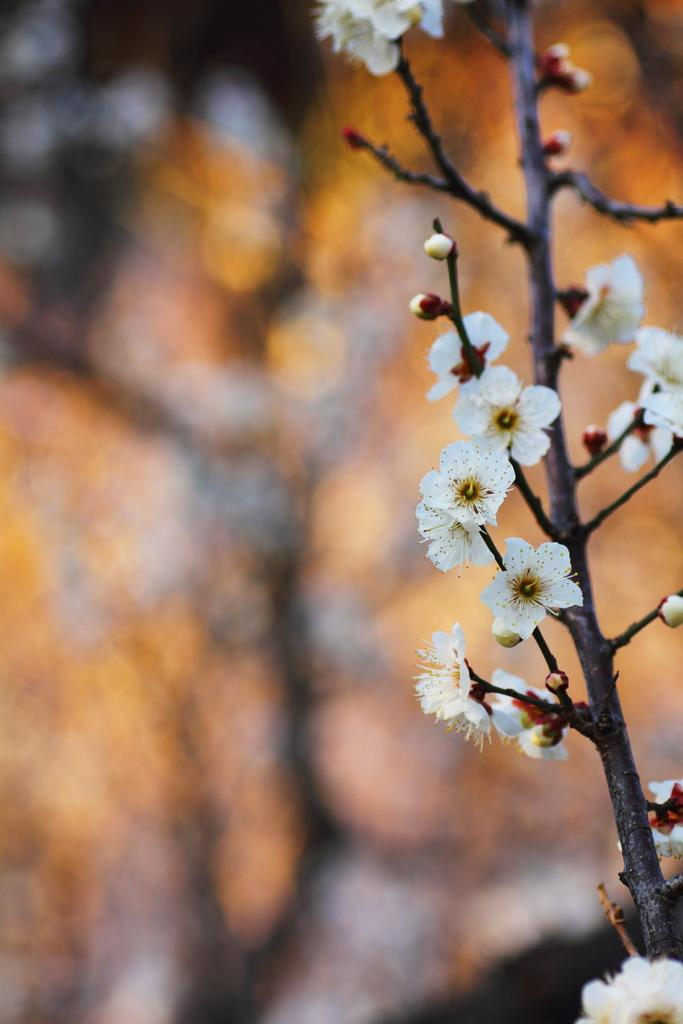What color are the flowers on the plant in the image? The flowers on the plant are white. What stage of growth are some of the flowers in? There are buds on the plant, indicating that some flowers are not yet fully bloomed. How would you describe the quality of the image's background? The image is blurry at the back. What might be present in the blurry background of the image? There might be trees in the blurry background. How many goldfish can be seen swimming in the image? There are no goldfish present in the image; it features a plant with white flowers and a blurry background. What type of roof is visible in the image? There is no roof visible in the image. 